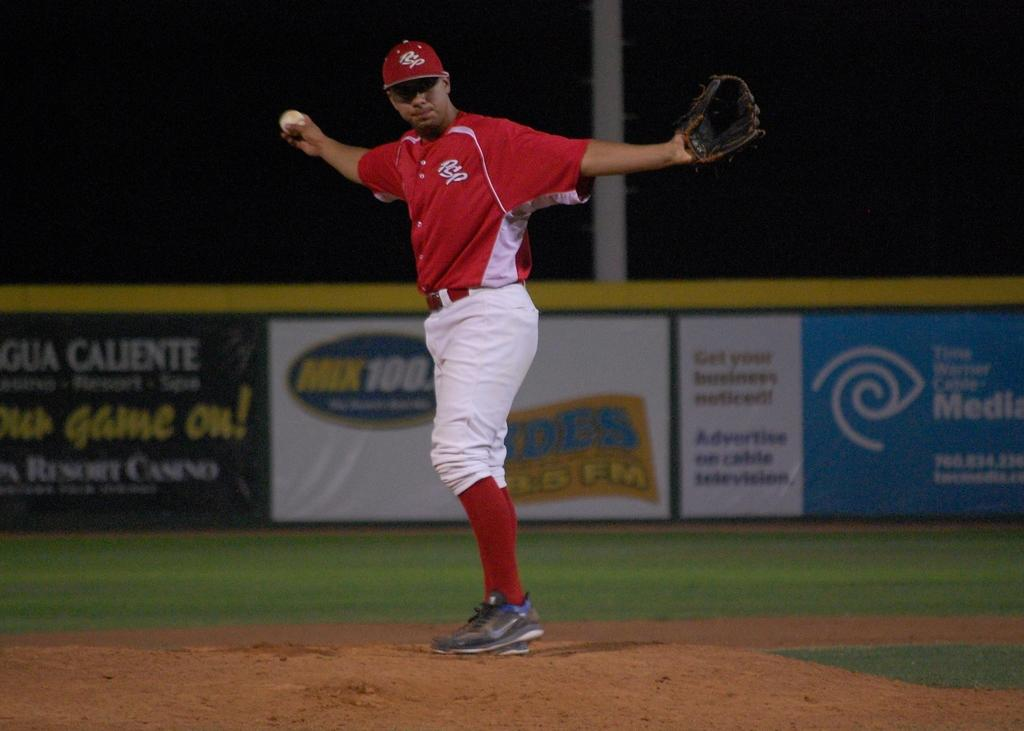<image>
Write a terse but informative summary of the picture. A baseball player standing on a pitching mound with a red jersey that says PSP on the front 